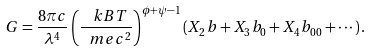Convert formula to latex. <formula><loc_0><loc_0><loc_500><loc_500>G = \frac { 8 \pi c } { \lambda ^ { 4 } } \left ( \frac { \ k B T } { \ m e c ^ { 2 } } \right ) ^ { \phi + \psi - 1 } \left ( X _ { 2 } b + X _ { 3 } b _ { 0 } + X _ { 4 } b _ { 0 0 } + \cdots \right ) .</formula> 